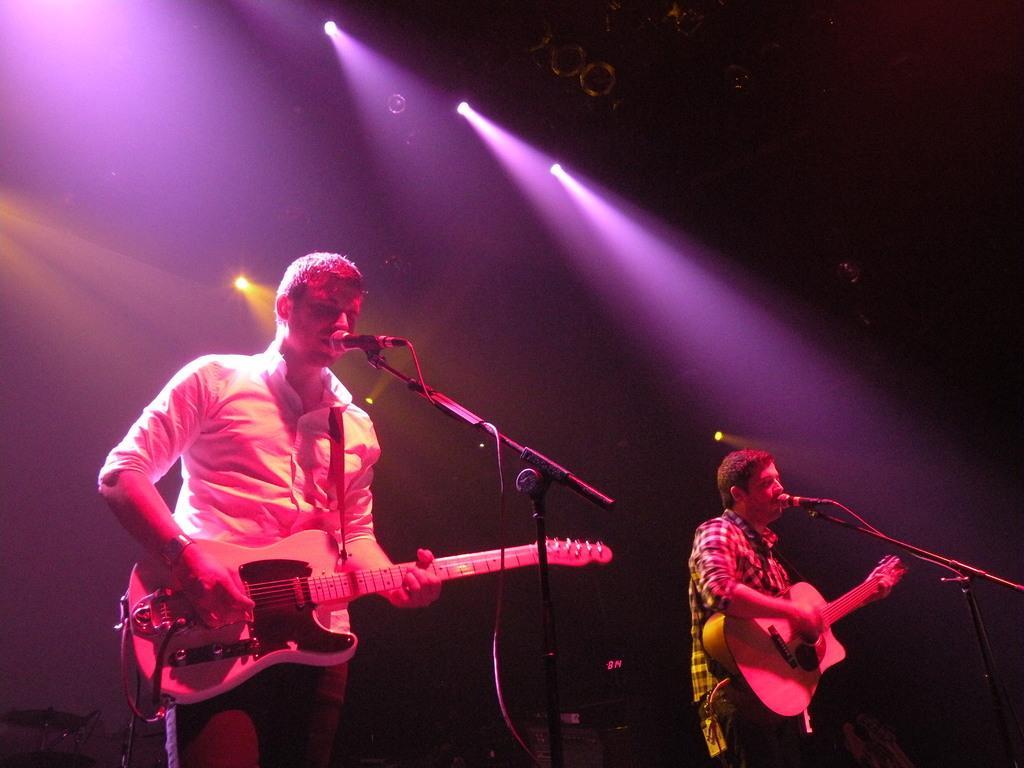Please provide a concise description of this image. In this image at the left bottom we can see a person holding guitar and seems like he is singing something, in front of him there is a microphone which he is using for singing loudly. On the right side, there is another person holding guitar and singing. It seems like some music concert is going. 